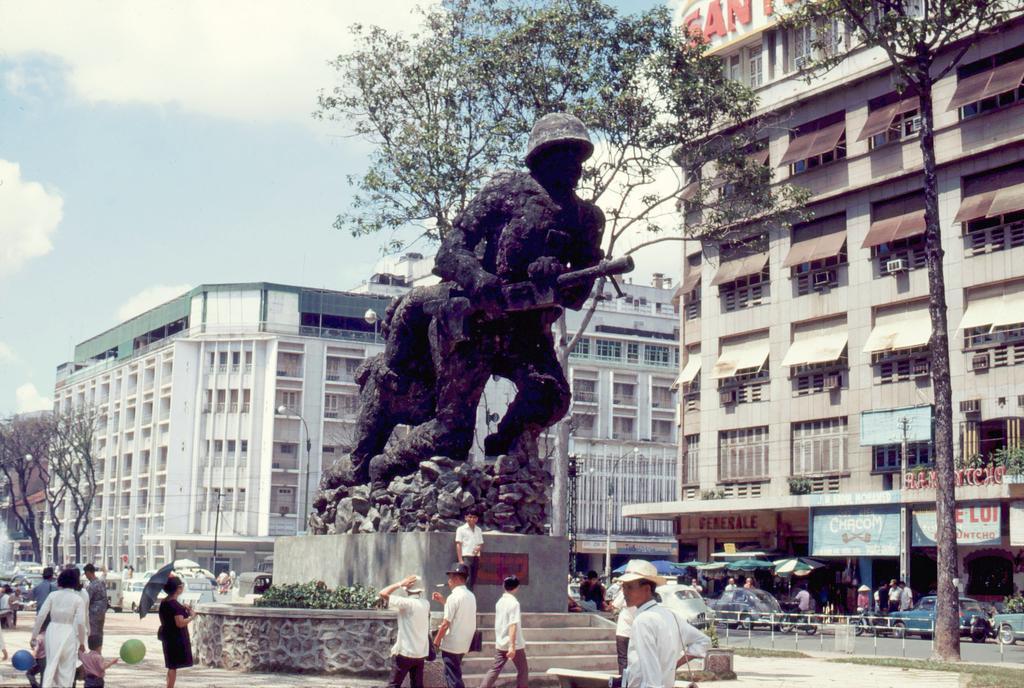How would you summarize this image in a sentence or two? In the image there is a statue in the middle with people walking all around the place, there are cars in the background, on the right side there are buildings and above its sky with clouds. 